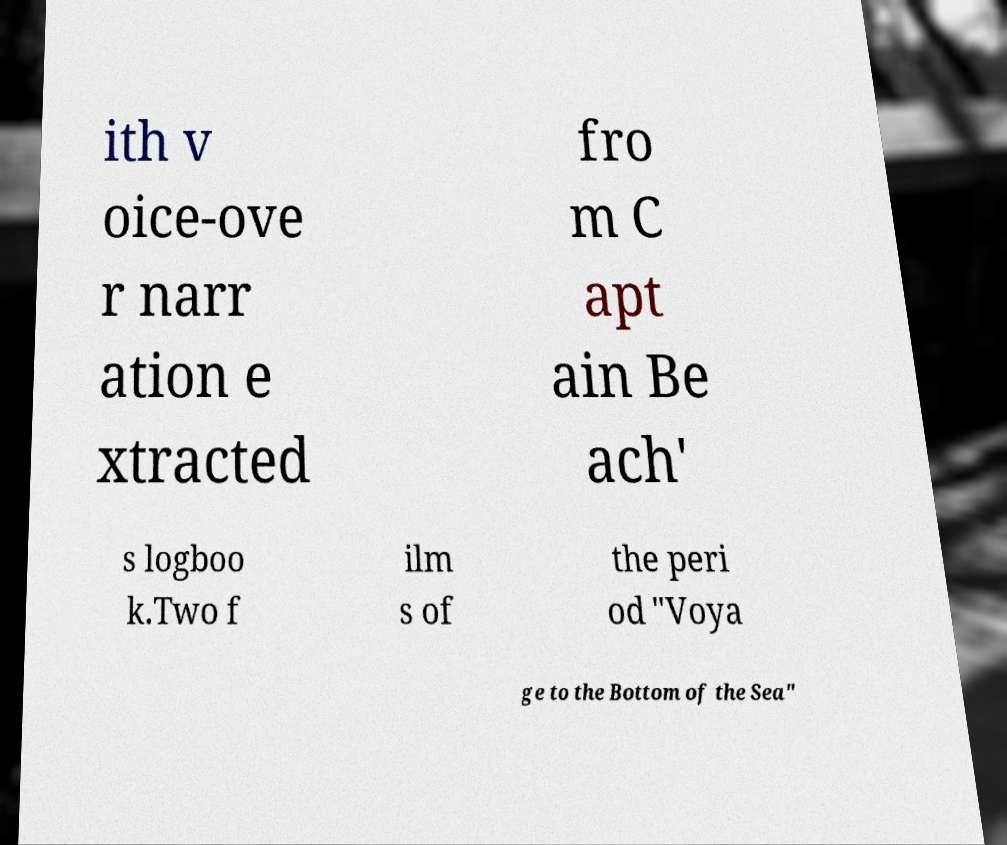Could you extract and type out the text from this image? ith v oice-ove r narr ation e xtracted fro m C apt ain Be ach' s logboo k.Two f ilm s of the peri od "Voya ge to the Bottom of the Sea" 